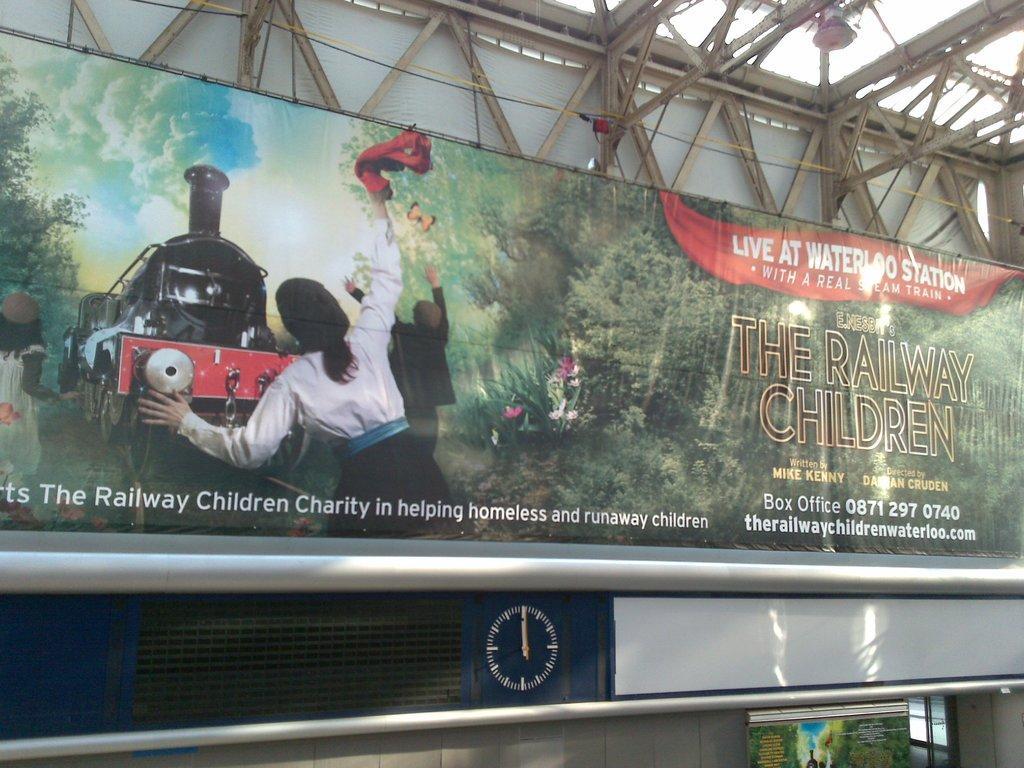How would you summarize this image in a sentence or two? In this image, this looks like a hoarding. I can see the picture of a train on the rack and three people standing. These are the trees and the letters on the hoarding. These look like the iron pillars. At the bottom of the image, that looks like a banner. 